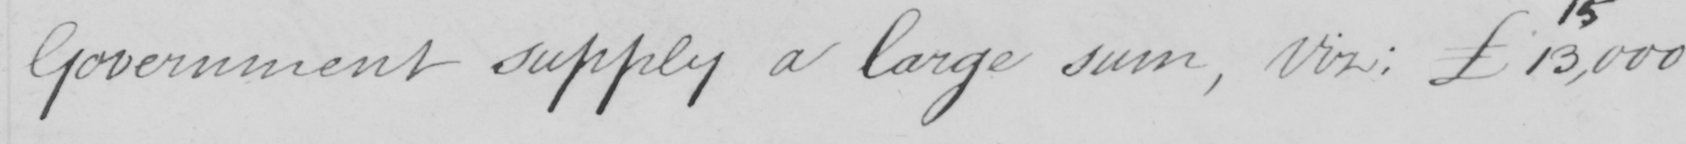Please provide the text content of this handwritten line. Government supply a large sum , viz :  £13,000 